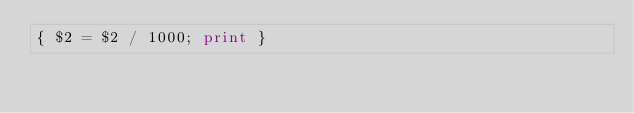Convert code to text. <code><loc_0><loc_0><loc_500><loc_500><_Awk_>{ $2 = $2 / 1000; print }
</code> 